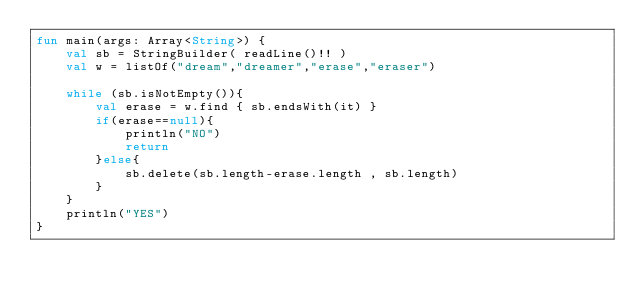Convert code to text. <code><loc_0><loc_0><loc_500><loc_500><_Kotlin_>fun main(args: Array<String>) {
    val sb = StringBuilder( readLine()!! )
    val w = listOf("dream","dreamer","erase","eraser")

    while (sb.isNotEmpty()){
        val erase = w.find { sb.endsWith(it) }
        if(erase==null){
            println("NO")
            return
        }else{
            sb.delete(sb.length-erase.length , sb.length)
        }
    }
    println("YES")
}</code> 